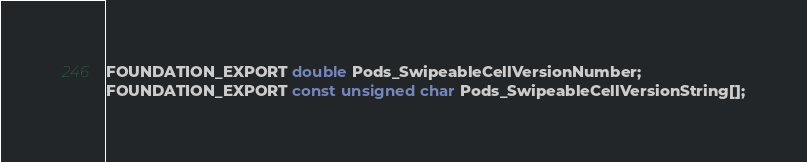Convert code to text. <code><loc_0><loc_0><loc_500><loc_500><_C_>FOUNDATION_EXPORT double Pods_SwipeableCellVersionNumber;
FOUNDATION_EXPORT const unsigned char Pods_SwipeableCellVersionString[];

</code> 